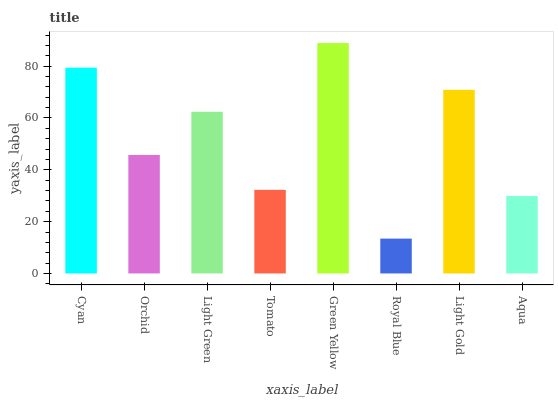Is Orchid the minimum?
Answer yes or no. No. Is Orchid the maximum?
Answer yes or no. No. Is Cyan greater than Orchid?
Answer yes or no. Yes. Is Orchid less than Cyan?
Answer yes or no. Yes. Is Orchid greater than Cyan?
Answer yes or no. No. Is Cyan less than Orchid?
Answer yes or no. No. Is Light Green the high median?
Answer yes or no. Yes. Is Orchid the low median?
Answer yes or no. Yes. Is Cyan the high median?
Answer yes or no. No. Is Light Green the low median?
Answer yes or no. No. 